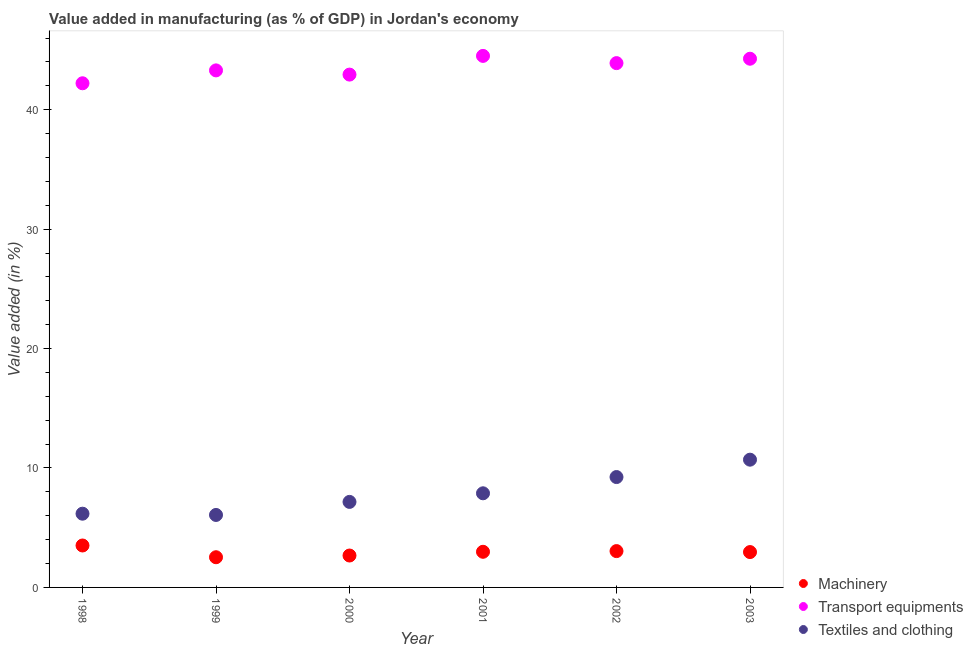What is the value added in manufacturing transport equipments in 1999?
Your answer should be compact. 43.29. Across all years, what is the maximum value added in manufacturing textile and clothing?
Give a very brief answer. 10.7. Across all years, what is the minimum value added in manufacturing transport equipments?
Make the answer very short. 42.21. What is the total value added in manufacturing machinery in the graph?
Your answer should be very brief. 17.7. What is the difference between the value added in manufacturing transport equipments in 1998 and that in 2003?
Provide a succinct answer. -2.06. What is the difference between the value added in manufacturing machinery in 2003 and the value added in manufacturing textile and clothing in 1999?
Provide a short and direct response. -3.11. What is the average value added in manufacturing textile and clothing per year?
Give a very brief answer. 7.87. In the year 2000, what is the difference between the value added in manufacturing machinery and value added in manufacturing textile and clothing?
Provide a succinct answer. -4.49. What is the ratio of the value added in manufacturing textile and clothing in 1999 to that in 2003?
Provide a succinct answer. 0.57. What is the difference between the highest and the second highest value added in manufacturing textile and clothing?
Keep it short and to the point. 1.46. What is the difference between the highest and the lowest value added in manufacturing transport equipments?
Keep it short and to the point. 2.29. In how many years, is the value added in manufacturing textile and clothing greater than the average value added in manufacturing textile and clothing taken over all years?
Your response must be concise. 3. Is the sum of the value added in manufacturing textile and clothing in 1999 and 2000 greater than the maximum value added in manufacturing transport equipments across all years?
Your answer should be compact. No. Does the value added in manufacturing machinery monotonically increase over the years?
Make the answer very short. No. How many dotlines are there?
Offer a terse response. 3. What is the difference between two consecutive major ticks on the Y-axis?
Your answer should be very brief. 10. What is the title of the graph?
Your response must be concise. Value added in manufacturing (as % of GDP) in Jordan's economy. Does "Machinery" appear as one of the legend labels in the graph?
Give a very brief answer. Yes. What is the label or title of the Y-axis?
Ensure brevity in your answer.  Value added (in %). What is the Value added (in %) in Machinery in 1998?
Ensure brevity in your answer.  3.51. What is the Value added (in %) in Transport equipments in 1998?
Give a very brief answer. 42.21. What is the Value added (in %) of Textiles and clothing in 1998?
Give a very brief answer. 6.17. What is the Value added (in %) in Machinery in 1999?
Offer a terse response. 2.53. What is the Value added (in %) in Transport equipments in 1999?
Provide a short and direct response. 43.29. What is the Value added (in %) of Textiles and clothing in 1999?
Offer a terse response. 6.07. What is the Value added (in %) of Machinery in 2000?
Your answer should be very brief. 2.67. What is the Value added (in %) of Transport equipments in 2000?
Give a very brief answer. 42.94. What is the Value added (in %) in Textiles and clothing in 2000?
Provide a short and direct response. 7.16. What is the Value added (in %) in Machinery in 2001?
Your answer should be very brief. 2.98. What is the Value added (in %) of Transport equipments in 2001?
Provide a short and direct response. 44.51. What is the Value added (in %) in Textiles and clothing in 2001?
Your response must be concise. 7.88. What is the Value added (in %) of Machinery in 2002?
Offer a very short reply. 3.04. What is the Value added (in %) in Transport equipments in 2002?
Provide a short and direct response. 43.9. What is the Value added (in %) of Textiles and clothing in 2002?
Offer a terse response. 9.24. What is the Value added (in %) of Machinery in 2003?
Provide a short and direct response. 2.96. What is the Value added (in %) in Transport equipments in 2003?
Offer a very short reply. 44.27. What is the Value added (in %) in Textiles and clothing in 2003?
Your response must be concise. 10.7. Across all years, what is the maximum Value added (in %) in Machinery?
Provide a succinct answer. 3.51. Across all years, what is the maximum Value added (in %) of Transport equipments?
Provide a succinct answer. 44.51. Across all years, what is the maximum Value added (in %) in Textiles and clothing?
Give a very brief answer. 10.7. Across all years, what is the minimum Value added (in %) of Machinery?
Provide a short and direct response. 2.53. Across all years, what is the minimum Value added (in %) of Transport equipments?
Offer a terse response. 42.21. Across all years, what is the minimum Value added (in %) in Textiles and clothing?
Provide a short and direct response. 6.07. What is the total Value added (in %) in Machinery in the graph?
Provide a succinct answer. 17.7. What is the total Value added (in %) in Transport equipments in the graph?
Offer a terse response. 261.13. What is the total Value added (in %) of Textiles and clothing in the graph?
Ensure brevity in your answer.  47.22. What is the difference between the Value added (in %) in Machinery in 1998 and that in 1999?
Offer a terse response. 0.98. What is the difference between the Value added (in %) of Transport equipments in 1998 and that in 1999?
Your answer should be compact. -1.08. What is the difference between the Value added (in %) in Textiles and clothing in 1998 and that in 1999?
Keep it short and to the point. 0.1. What is the difference between the Value added (in %) of Machinery in 1998 and that in 2000?
Provide a short and direct response. 0.84. What is the difference between the Value added (in %) in Transport equipments in 1998 and that in 2000?
Offer a very short reply. -0.73. What is the difference between the Value added (in %) of Textiles and clothing in 1998 and that in 2000?
Your response must be concise. -0.99. What is the difference between the Value added (in %) of Machinery in 1998 and that in 2001?
Offer a very short reply. 0.53. What is the difference between the Value added (in %) of Transport equipments in 1998 and that in 2001?
Make the answer very short. -2.29. What is the difference between the Value added (in %) of Textiles and clothing in 1998 and that in 2001?
Offer a terse response. -1.71. What is the difference between the Value added (in %) of Machinery in 1998 and that in 2002?
Your answer should be compact. 0.47. What is the difference between the Value added (in %) of Transport equipments in 1998 and that in 2002?
Your answer should be compact. -1.69. What is the difference between the Value added (in %) in Textiles and clothing in 1998 and that in 2002?
Your answer should be compact. -3.07. What is the difference between the Value added (in %) in Machinery in 1998 and that in 2003?
Your answer should be compact. 0.55. What is the difference between the Value added (in %) of Transport equipments in 1998 and that in 2003?
Provide a succinct answer. -2.06. What is the difference between the Value added (in %) in Textiles and clothing in 1998 and that in 2003?
Your answer should be very brief. -4.52. What is the difference between the Value added (in %) in Machinery in 1999 and that in 2000?
Provide a short and direct response. -0.14. What is the difference between the Value added (in %) in Transport equipments in 1999 and that in 2000?
Your response must be concise. 0.35. What is the difference between the Value added (in %) in Textiles and clothing in 1999 and that in 2000?
Give a very brief answer. -1.09. What is the difference between the Value added (in %) in Machinery in 1999 and that in 2001?
Make the answer very short. -0.46. What is the difference between the Value added (in %) of Transport equipments in 1999 and that in 2001?
Your answer should be compact. -1.21. What is the difference between the Value added (in %) in Textiles and clothing in 1999 and that in 2001?
Offer a very short reply. -1.81. What is the difference between the Value added (in %) in Machinery in 1999 and that in 2002?
Your response must be concise. -0.51. What is the difference between the Value added (in %) of Transport equipments in 1999 and that in 2002?
Offer a terse response. -0.61. What is the difference between the Value added (in %) in Textiles and clothing in 1999 and that in 2002?
Keep it short and to the point. -3.17. What is the difference between the Value added (in %) in Machinery in 1999 and that in 2003?
Offer a very short reply. -0.43. What is the difference between the Value added (in %) in Transport equipments in 1999 and that in 2003?
Provide a short and direct response. -0.98. What is the difference between the Value added (in %) in Textiles and clothing in 1999 and that in 2003?
Give a very brief answer. -4.63. What is the difference between the Value added (in %) of Machinery in 2000 and that in 2001?
Offer a very short reply. -0.31. What is the difference between the Value added (in %) of Transport equipments in 2000 and that in 2001?
Give a very brief answer. -1.57. What is the difference between the Value added (in %) of Textiles and clothing in 2000 and that in 2001?
Offer a terse response. -0.72. What is the difference between the Value added (in %) of Machinery in 2000 and that in 2002?
Provide a short and direct response. -0.37. What is the difference between the Value added (in %) of Transport equipments in 2000 and that in 2002?
Your response must be concise. -0.96. What is the difference between the Value added (in %) of Textiles and clothing in 2000 and that in 2002?
Your answer should be very brief. -2.08. What is the difference between the Value added (in %) in Machinery in 2000 and that in 2003?
Make the answer very short. -0.29. What is the difference between the Value added (in %) of Transport equipments in 2000 and that in 2003?
Provide a succinct answer. -1.33. What is the difference between the Value added (in %) in Textiles and clothing in 2000 and that in 2003?
Keep it short and to the point. -3.54. What is the difference between the Value added (in %) in Machinery in 2001 and that in 2002?
Offer a very short reply. -0.06. What is the difference between the Value added (in %) of Transport equipments in 2001 and that in 2002?
Give a very brief answer. 0.61. What is the difference between the Value added (in %) of Textiles and clothing in 2001 and that in 2002?
Your answer should be compact. -1.36. What is the difference between the Value added (in %) of Machinery in 2001 and that in 2003?
Provide a short and direct response. 0.02. What is the difference between the Value added (in %) in Transport equipments in 2001 and that in 2003?
Your answer should be very brief. 0.24. What is the difference between the Value added (in %) of Textiles and clothing in 2001 and that in 2003?
Offer a terse response. -2.82. What is the difference between the Value added (in %) in Machinery in 2002 and that in 2003?
Keep it short and to the point. 0.08. What is the difference between the Value added (in %) in Transport equipments in 2002 and that in 2003?
Ensure brevity in your answer.  -0.37. What is the difference between the Value added (in %) of Textiles and clothing in 2002 and that in 2003?
Provide a short and direct response. -1.46. What is the difference between the Value added (in %) of Machinery in 1998 and the Value added (in %) of Transport equipments in 1999?
Your response must be concise. -39.78. What is the difference between the Value added (in %) in Machinery in 1998 and the Value added (in %) in Textiles and clothing in 1999?
Provide a succinct answer. -2.56. What is the difference between the Value added (in %) in Transport equipments in 1998 and the Value added (in %) in Textiles and clothing in 1999?
Make the answer very short. 36.15. What is the difference between the Value added (in %) of Machinery in 1998 and the Value added (in %) of Transport equipments in 2000?
Your answer should be very brief. -39.43. What is the difference between the Value added (in %) in Machinery in 1998 and the Value added (in %) in Textiles and clothing in 2000?
Your answer should be compact. -3.65. What is the difference between the Value added (in %) in Transport equipments in 1998 and the Value added (in %) in Textiles and clothing in 2000?
Make the answer very short. 35.05. What is the difference between the Value added (in %) in Machinery in 1998 and the Value added (in %) in Transport equipments in 2001?
Provide a succinct answer. -41. What is the difference between the Value added (in %) in Machinery in 1998 and the Value added (in %) in Textiles and clothing in 2001?
Provide a short and direct response. -4.37. What is the difference between the Value added (in %) in Transport equipments in 1998 and the Value added (in %) in Textiles and clothing in 2001?
Offer a very short reply. 34.33. What is the difference between the Value added (in %) in Machinery in 1998 and the Value added (in %) in Transport equipments in 2002?
Your response must be concise. -40.39. What is the difference between the Value added (in %) of Machinery in 1998 and the Value added (in %) of Textiles and clothing in 2002?
Offer a terse response. -5.73. What is the difference between the Value added (in %) of Transport equipments in 1998 and the Value added (in %) of Textiles and clothing in 2002?
Your answer should be very brief. 32.97. What is the difference between the Value added (in %) in Machinery in 1998 and the Value added (in %) in Transport equipments in 2003?
Offer a terse response. -40.76. What is the difference between the Value added (in %) of Machinery in 1998 and the Value added (in %) of Textiles and clothing in 2003?
Your answer should be compact. -7.19. What is the difference between the Value added (in %) of Transport equipments in 1998 and the Value added (in %) of Textiles and clothing in 2003?
Offer a very short reply. 31.52. What is the difference between the Value added (in %) of Machinery in 1999 and the Value added (in %) of Transport equipments in 2000?
Offer a terse response. -40.41. What is the difference between the Value added (in %) of Machinery in 1999 and the Value added (in %) of Textiles and clothing in 2000?
Your response must be concise. -4.63. What is the difference between the Value added (in %) in Transport equipments in 1999 and the Value added (in %) in Textiles and clothing in 2000?
Give a very brief answer. 36.13. What is the difference between the Value added (in %) of Machinery in 1999 and the Value added (in %) of Transport equipments in 2001?
Your answer should be compact. -41.98. What is the difference between the Value added (in %) in Machinery in 1999 and the Value added (in %) in Textiles and clothing in 2001?
Your response must be concise. -5.35. What is the difference between the Value added (in %) of Transport equipments in 1999 and the Value added (in %) of Textiles and clothing in 2001?
Your response must be concise. 35.41. What is the difference between the Value added (in %) in Machinery in 1999 and the Value added (in %) in Transport equipments in 2002?
Ensure brevity in your answer.  -41.37. What is the difference between the Value added (in %) in Machinery in 1999 and the Value added (in %) in Textiles and clothing in 2002?
Keep it short and to the point. -6.71. What is the difference between the Value added (in %) in Transport equipments in 1999 and the Value added (in %) in Textiles and clothing in 2002?
Ensure brevity in your answer.  34.05. What is the difference between the Value added (in %) in Machinery in 1999 and the Value added (in %) in Transport equipments in 2003?
Your response must be concise. -41.74. What is the difference between the Value added (in %) of Machinery in 1999 and the Value added (in %) of Textiles and clothing in 2003?
Your answer should be very brief. -8.17. What is the difference between the Value added (in %) in Transport equipments in 1999 and the Value added (in %) in Textiles and clothing in 2003?
Your answer should be very brief. 32.6. What is the difference between the Value added (in %) of Machinery in 2000 and the Value added (in %) of Transport equipments in 2001?
Ensure brevity in your answer.  -41.84. What is the difference between the Value added (in %) of Machinery in 2000 and the Value added (in %) of Textiles and clothing in 2001?
Provide a short and direct response. -5.21. What is the difference between the Value added (in %) of Transport equipments in 2000 and the Value added (in %) of Textiles and clothing in 2001?
Provide a succinct answer. 35.06. What is the difference between the Value added (in %) of Machinery in 2000 and the Value added (in %) of Transport equipments in 2002?
Ensure brevity in your answer.  -41.23. What is the difference between the Value added (in %) of Machinery in 2000 and the Value added (in %) of Textiles and clothing in 2002?
Provide a succinct answer. -6.57. What is the difference between the Value added (in %) in Transport equipments in 2000 and the Value added (in %) in Textiles and clothing in 2002?
Give a very brief answer. 33.7. What is the difference between the Value added (in %) in Machinery in 2000 and the Value added (in %) in Transport equipments in 2003?
Keep it short and to the point. -41.6. What is the difference between the Value added (in %) of Machinery in 2000 and the Value added (in %) of Textiles and clothing in 2003?
Your answer should be very brief. -8.03. What is the difference between the Value added (in %) of Transport equipments in 2000 and the Value added (in %) of Textiles and clothing in 2003?
Give a very brief answer. 32.24. What is the difference between the Value added (in %) of Machinery in 2001 and the Value added (in %) of Transport equipments in 2002?
Ensure brevity in your answer.  -40.92. What is the difference between the Value added (in %) in Machinery in 2001 and the Value added (in %) in Textiles and clothing in 2002?
Your answer should be very brief. -6.26. What is the difference between the Value added (in %) in Transport equipments in 2001 and the Value added (in %) in Textiles and clothing in 2002?
Offer a very short reply. 35.27. What is the difference between the Value added (in %) in Machinery in 2001 and the Value added (in %) in Transport equipments in 2003?
Your response must be concise. -41.29. What is the difference between the Value added (in %) in Machinery in 2001 and the Value added (in %) in Textiles and clothing in 2003?
Provide a succinct answer. -7.71. What is the difference between the Value added (in %) in Transport equipments in 2001 and the Value added (in %) in Textiles and clothing in 2003?
Ensure brevity in your answer.  33.81. What is the difference between the Value added (in %) of Machinery in 2002 and the Value added (in %) of Transport equipments in 2003?
Keep it short and to the point. -41.23. What is the difference between the Value added (in %) in Machinery in 2002 and the Value added (in %) in Textiles and clothing in 2003?
Offer a terse response. -7.66. What is the difference between the Value added (in %) of Transport equipments in 2002 and the Value added (in %) of Textiles and clothing in 2003?
Provide a short and direct response. 33.2. What is the average Value added (in %) in Machinery per year?
Your answer should be compact. 2.95. What is the average Value added (in %) in Transport equipments per year?
Keep it short and to the point. 43.52. What is the average Value added (in %) in Textiles and clothing per year?
Your answer should be very brief. 7.87. In the year 1998, what is the difference between the Value added (in %) in Machinery and Value added (in %) in Transport equipments?
Offer a terse response. -38.7. In the year 1998, what is the difference between the Value added (in %) of Machinery and Value added (in %) of Textiles and clothing?
Offer a very short reply. -2.66. In the year 1998, what is the difference between the Value added (in %) in Transport equipments and Value added (in %) in Textiles and clothing?
Offer a very short reply. 36.04. In the year 1999, what is the difference between the Value added (in %) of Machinery and Value added (in %) of Transport equipments?
Make the answer very short. -40.77. In the year 1999, what is the difference between the Value added (in %) in Machinery and Value added (in %) in Textiles and clothing?
Give a very brief answer. -3.54. In the year 1999, what is the difference between the Value added (in %) of Transport equipments and Value added (in %) of Textiles and clothing?
Provide a succinct answer. 37.22. In the year 2000, what is the difference between the Value added (in %) of Machinery and Value added (in %) of Transport equipments?
Offer a terse response. -40.27. In the year 2000, what is the difference between the Value added (in %) of Machinery and Value added (in %) of Textiles and clothing?
Ensure brevity in your answer.  -4.49. In the year 2000, what is the difference between the Value added (in %) of Transport equipments and Value added (in %) of Textiles and clothing?
Give a very brief answer. 35.78. In the year 2001, what is the difference between the Value added (in %) of Machinery and Value added (in %) of Transport equipments?
Your answer should be compact. -41.52. In the year 2001, what is the difference between the Value added (in %) in Machinery and Value added (in %) in Textiles and clothing?
Offer a very short reply. -4.9. In the year 2001, what is the difference between the Value added (in %) of Transport equipments and Value added (in %) of Textiles and clothing?
Your answer should be compact. 36.63. In the year 2002, what is the difference between the Value added (in %) of Machinery and Value added (in %) of Transport equipments?
Offer a terse response. -40.86. In the year 2002, what is the difference between the Value added (in %) of Machinery and Value added (in %) of Textiles and clothing?
Provide a succinct answer. -6.2. In the year 2002, what is the difference between the Value added (in %) in Transport equipments and Value added (in %) in Textiles and clothing?
Keep it short and to the point. 34.66. In the year 2003, what is the difference between the Value added (in %) in Machinery and Value added (in %) in Transport equipments?
Offer a very short reply. -41.31. In the year 2003, what is the difference between the Value added (in %) of Machinery and Value added (in %) of Textiles and clothing?
Make the answer very short. -7.74. In the year 2003, what is the difference between the Value added (in %) in Transport equipments and Value added (in %) in Textiles and clothing?
Your answer should be compact. 33.57. What is the ratio of the Value added (in %) of Machinery in 1998 to that in 1999?
Your response must be concise. 1.39. What is the ratio of the Value added (in %) of Transport equipments in 1998 to that in 1999?
Your answer should be compact. 0.98. What is the ratio of the Value added (in %) of Textiles and clothing in 1998 to that in 1999?
Offer a very short reply. 1.02. What is the ratio of the Value added (in %) in Machinery in 1998 to that in 2000?
Provide a short and direct response. 1.31. What is the ratio of the Value added (in %) in Transport equipments in 1998 to that in 2000?
Your answer should be very brief. 0.98. What is the ratio of the Value added (in %) in Textiles and clothing in 1998 to that in 2000?
Your answer should be very brief. 0.86. What is the ratio of the Value added (in %) in Machinery in 1998 to that in 2001?
Ensure brevity in your answer.  1.18. What is the ratio of the Value added (in %) of Transport equipments in 1998 to that in 2001?
Your response must be concise. 0.95. What is the ratio of the Value added (in %) of Textiles and clothing in 1998 to that in 2001?
Give a very brief answer. 0.78. What is the ratio of the Value added (in %) of Machinery in 1998 to that in 2002?
Give a very brief answer. 1.15. What is the ratio of the Value added (in %) of Transport equipments in 1998 to that in 2002?
Provide a succinct answer. 0.96. What is the ratio of the Value added (in %) of Textiles and clothing in 1998 to that in 2002?
Keep it short and to the point. 0.67. What is the ratio of the Value added (in %) of Machinery in 1998 to that in 2003?
Make the answer very short. 1.19. What is the ratio of the Value added (in %) in Transport equipments in 1998 to that in 2003?
Your answer should be compact. 0.95. What is the ratio of the Value added (in %) in Textiles and clothing in 1998 to that in 2003?
Your response must be concise. 0.58. What is the ratio of the Value added (in %) in Machinery in 1999 to that in 2000?
Ensure brevity in your answer.  0.95. What is the ratio of the Value added (in %) in Transport equipments in 1999 to that in 2000?
Keep it short and to the point. 1.01. What is the ratio of the Value added (in %) in Textiles and clothing in 1999 to that in 2000?
Your response must be concise. 0.85. What is the ratio of the Value added (in %) in Machinery in 1999 to that in 2001?
Your answer should be very brief. 0.85. What is the ratio of the Value added (in %) of Transport equipments in 1999 to that in 2001?
Provide a short and direct response. 0.97. What is the ratio of the Value added (in %) of Textiles and clothing in 1999 to that in 2001?
Make the answer very short. 0.77. What is the ratio of the Value added (in %) of Machinery in 1999 to that in 2002?
Offer a very short reply. 0.83. What is the ratio of the Value added (in %) of Transport equipments in 1999 to that in 2002?
Provide a succinct answer. 0.99. What is the ratio of the Value added (in %) in Textiles and clothing in 1999 to that in 2002?
Provide a short and direct response. 0.66. What is the ratio of the Value added (in %) of Machinery in 1999 to that in 2003?
Your answer should be compact. 0.85. What is the ratio of the Value added (in %) in Transport equipments in 1999 to that in 2003?
Keep it short and to the point. 0.98. What is the ratio of the Value added (in %) of Textiles and clothing in 1999 to that in 2003?
Keep it short and to the point. 0.57. What is the ratio of the Value added (in %) in Machinery in 2000 to that in 2001?
Offer a terse response. 0.9. What is the ratio of the Value added (in %) in Transport equipments in 2000 to that in 2001?
Offer a very short reply. 0.96. What is the ratio of the Value added (in %) of Textiles and clothing in 2000 to that in 2001?
Ensure brevity in your answer.  0.91. What is the ratio of the Value added (in %) of Machinery in 2000 to that in 2002?
Your answer should be compact. 0.88. What is the ratio of the Value added (in %) of Transport equipments in 2000 to that in 2002?
Keep it short and to the point. 0.98. What is the ratio of the Value added (in %) of Textiles and clothing in 2000 to that in 2002?
Offer a terse response. 0.77. What is the ratio of the Value added (in %) of Machinery in 2000 to that in 2003?
Offer a terse response. 0.9. What is the ratio of the Value added (in %) of Transport equipments in 2000 to that in 2003?
Give a very brief answer. 0.97. What is the ratio of the Value added (in %) of Textiles and clothing in 2000 to that in 2003?
Your response must be concise. 0.67. What is the ratio of the Value added (in %) in Machinery in 2001 to that in 2002?
Give a very brief answer. 0.98. What is the ratio of the Value added (in %) of Transport equipments in 2001 to that in 2002?
Your answer should be very brief. 1.01. What is the ratio of the Value added (in %) in Textiles and clothing in 2001 to that in 2002?
Offer a terse response. 0.85. What is the ratio of the Value added (in %) in Transport equipments in 2001 to that in 2003?
Offer a terse response. 1.01. What is the ratio of the Value added (in %) of Textiles and clothing in 2001 to that in 2003?
Keep it short and to the point. 0.74. What is the ratio of the Value added (in %) in Machinery in 2002 to that in 2003?
Your answer should be compact. 1.03. What is the ratio of the Value added (in %) of Textiles and clothing in 2002 to that in 2003?
Offer a very short reply. 0.86. What is the difference between the highest and the second highest Value added (in %) in Machinery?
Your answer should be very brief. 0.47. What is the difference between the highest and the second highest Value added (in %) in Transport equipments?
Your answer should be very brief. 0.24. What is the difference between the highest and the second highest Value added (in %) in Textiles and clothing?
Make the answer very short. 1.46. What is the difference between the highest and the lowest Value added (in %) of Machinery?
Keep it short and to the point. 0.98. What is the difference between the highest and the lowest Value added (in %) in Transport equipments?
Make the answer very short. 2.29. What is the difference between the highest and the lowest Value added (in %) in Textiles and clothing?
Provide a short and direct response. 4.63. 